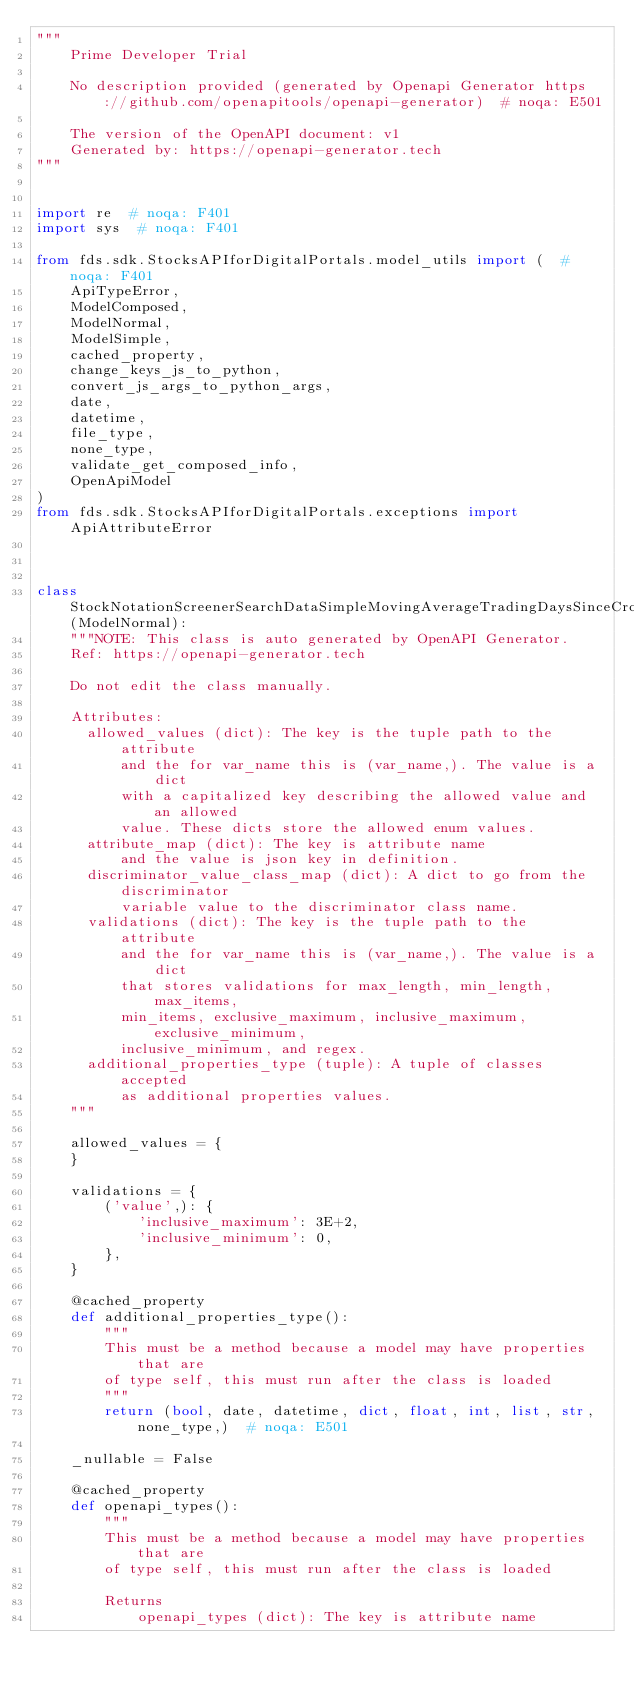Convert code to text. <code><loc_0><loc_0><loc_500><loc_500><_Python_>"""
    Prime Developer Trial

    No description provided (generated by Openapi Generator https://github.com/openapitools/openapi-generator)  # noqa: E501

    The version of the OpenAPI document: v1
    Generated by: https://openapi-generator.tech
"""


import re  # noqa: F401
import sys  # noqa: F401

from fds.sdk.StocksAPIforDigitalPortals.model_utils import (  # noqa: F401
    ApiTypeError,
    ModelComposed,
    ModelNormal,
    ModelSimple,
    cached_property,
    change_keys_js_to_python,
    convert_js_args_to_python_args,
    date,
    datetime,
    file_type,
    none_type,
    validate_get_composed_info,
    OpenApiModel
)
from fds.sdk.StocksAPIforDigitalPortals.exceptions import ApiAttributeError



class StockNotationScreenerSearchDataSimpleMovingAverageTradingDaysSinceCrossoverSma50vs200NumberDaysMaximum(ModelNormal):
    """NOTE: This class is auto generated by OpenAPI Generator.
    Ref: https://openapi-generator.tech

    Do not edit the class manually.

    Attributes:
      allowed_values (dict): The key is the tuple path to the attribute
          and the for var_name this is (var_name,). The value is a dict
          with a capitalized key describing the allowed value and an allowed
          value. These dicts store the allowed enum values.
      attribute_map (dict): The key is attribute name
          and the value is json key in definition.
      discriminator_value_class_map (dict): A dict to go from the discriminator
          variable value to the discriminator class name.
      validations (dict): The key is the tuple path to the attribute
          and the for var_name this is (var_name,). The value is a dict
          that stores validations for max_length, min_length, max_items,
          min_items, exclusive_maximum, inclusive_maximum, exclusive_minimum,
          inclusive_minimum, and regex.
      additional_properties_type (tuple): A tuple of classes accepted
          as additional properties values.
    """

    allowed_values = {
    }

    validations = {
        ('value',): {
            'inclusive_maximum': 3E+2,
            'inclusive_minimum': 0,
        },
    }

    @cached_property
    def additional_properties_type():
        """
        This must be a method because a model may have properties that are
        of type self, this must run after the class is loaded
        """
        return (bool, date, datetime, dict, float, int, list, str, none_type,)  # noqa: E501

    _nullable = False

    @cached_property
    def openapi_types():
        """
        This must be a method because a model may have properties that are
        of type self, this must run after the class is loaded

        Returns
            openapi_types (dict): The key is attribute name</code> 